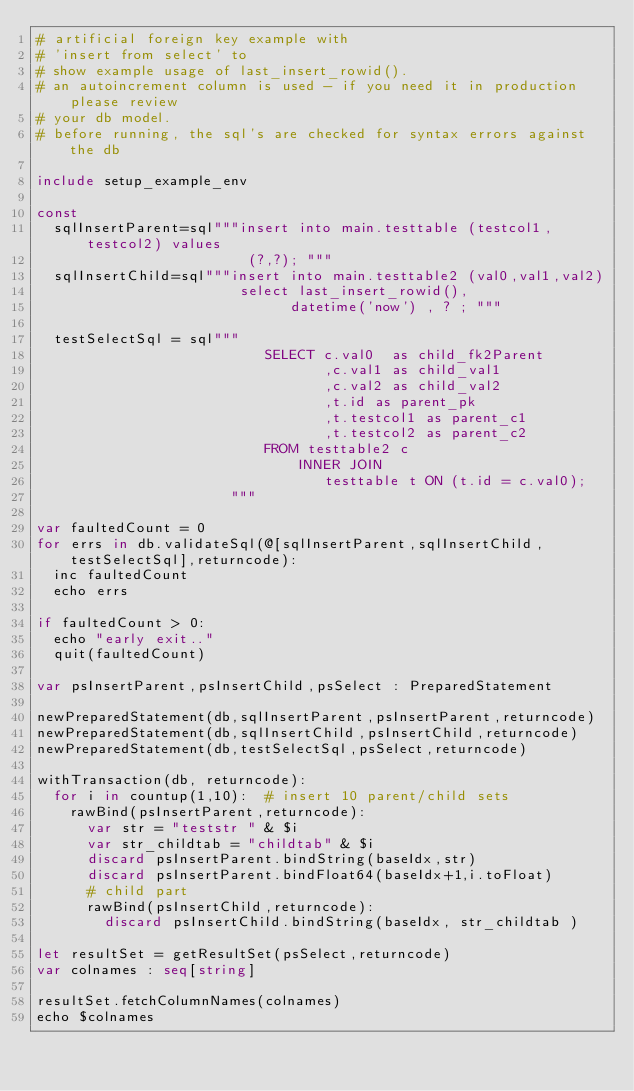<code> <loc_0><loc_0><loc_500><loc_500><_Nim_># artificial foreign key example with 
# 'insert from select' to
# show example usage of last_insert_rowid().
# an autoincrement column is used - if you need it in production please review
# your db model.
# before running, the sql's are checked for syntax errors against the db

include setup_example_env

const
  sqlInsertParent=sql"""insert into main.testtable (testcol1,testcol2) values 
                         (?,?); """
  sqlInsertChild=sql"""insert into main.testtable2 (val0,val1,val2)
                        select last_insert_rowid(),
                              datetime('now') , ? ; """
  
  testSelectSql = sql"""
                           SELECT c.val0  as child_fk2Parent
                                  ,c.val1 as child_val1
                                  ,c.val2 as child_val2
                                  ,t.id as parent_pk
                                  ,t.testcol1 as parent_c1
                                  ,t.testcol2 as parent_c2
                           FROM testtable2 c
                               INNER JOIN
                                  testtable t ON (t.id = c.val0);
                       """

var faultedCount = 0
for errs in db.validateSql(@[sqlInsertParent,sqlInsertChild,testSelectSql],returncode):
  inc faultedCount
  echo errs

if faultedCount > 0:
  echo "early exit.."
  quit(faultedCount)

var psInsertParent,psInsertChild,psSelect : PreparedStatement  

newPreparedStatement(db,sqlInsertParent,psInsertParent,returncode) 
newPreparedStatement(db,sqlInsertChild,psInsertChild,returncode) 
newPreparedStatement(db,testSelectSql,psSelect,returncode)                  

withTransaction(db, returncode):
  for i in countup(1,10):  # insert 10 parent/child sets 
    rawBind(psInsertParent,returncode):  
      var str = "teststr " & $i
      var str_childtab = "childtab" & $i
      discard psInsertParent.bindString(baseIdx,str)
      discard psInsertParent.bindFloat64(baseIdx+1,i.toFloat)
      # child part
      rawBind(psInsertChild,returncode):
        discard psInsertChild.bindString(baseIdx, str_childtab )

let resultSet = getResultSet(psSelect,returncode)
var colnames : seq[string]

resultSet.fetchColumnNames(colnames)
echo $colnames 
</code> 